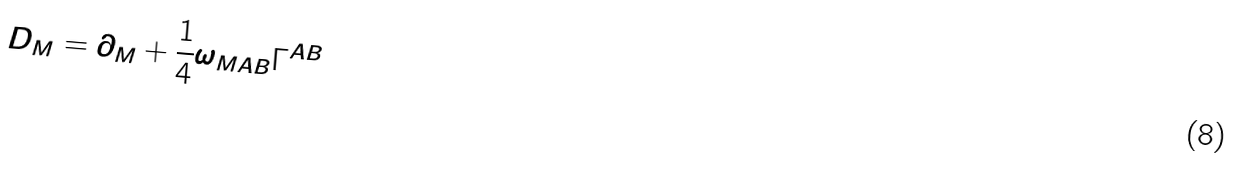Convert formula to latex. <formula><loc_0><loc_0><loc_500><loc_500>D _ { M } = \partial _ { M } + { \frac { 1 } { 4 } } \omega _ { M A B } \Gamma ^ { A B }</formula> 